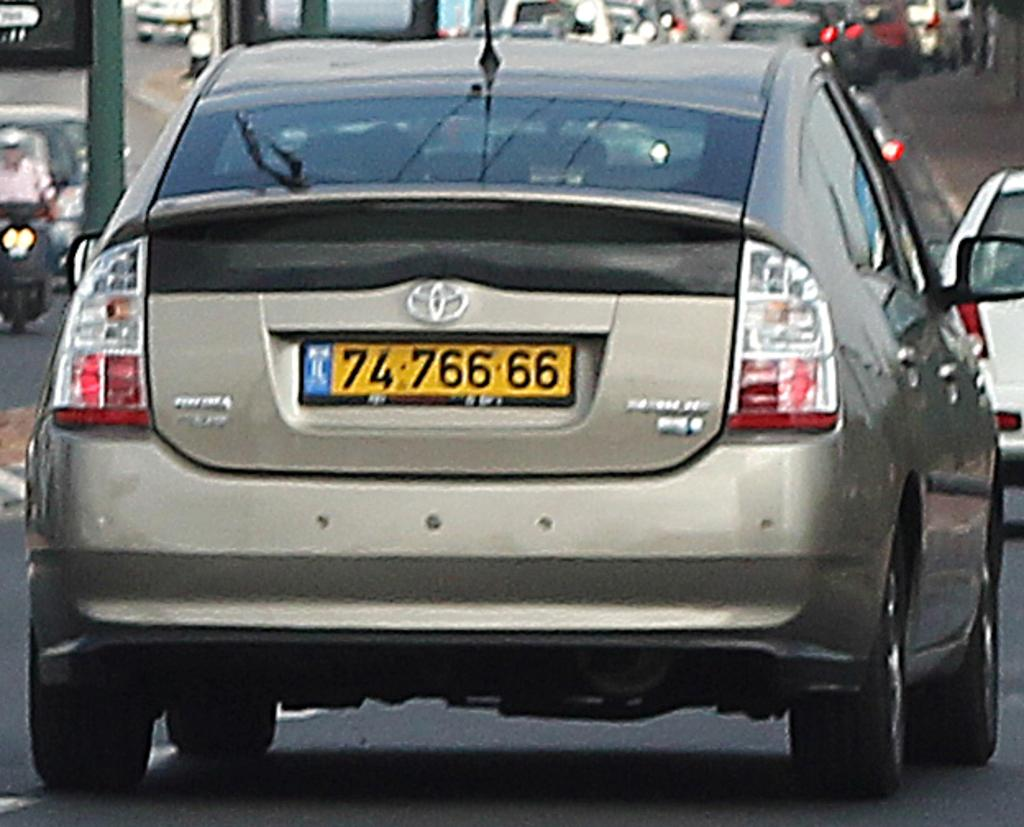<image>
Create a compact narrative representing the image presented. A car has the number 7476666 on the license plate. 